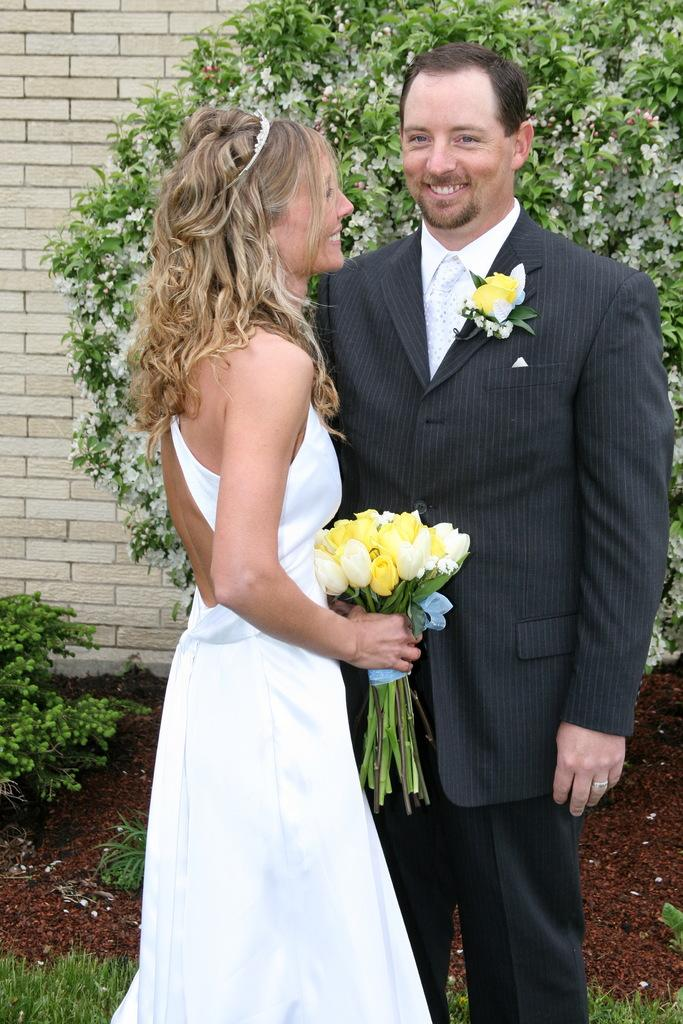How many people are in the image? Two persons are standing in the middle of the image. What are the people doing in the image? The persons are smiling and holding flowers. What can be seen in the background of the image? There are plants and a wall visible in the background. Can you see the toes of the persons in the image? There is no indication of the persons' feet or toes in the image. What type of crow is sitting on the person's shoulder in the image? There is no crow present in the image. 